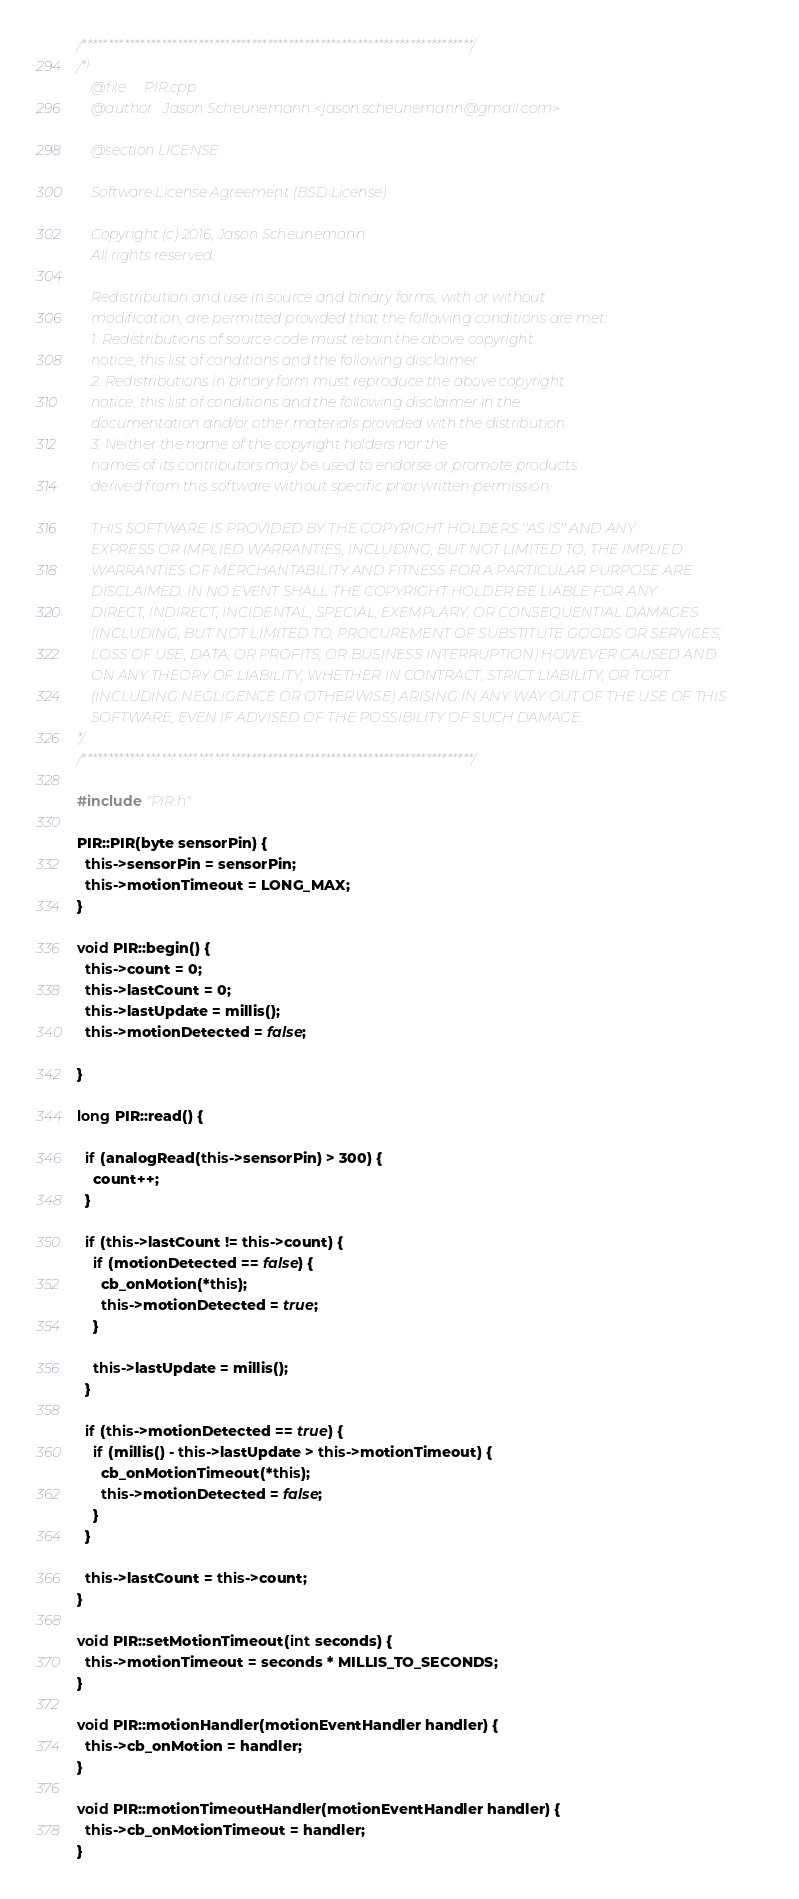Convert code to text. <code><loc_0><loc_0><loc_500><loc_500><_C++_>/**************************************************************************/
/*!
    @file     PIR.cpp
    @author   Jason Scheunemann <jason.scheunemann@gmail.com>

    @section LICENSE

    Software License Agreement (BSD License)

    Copyright (c) 2016, Jason Scheunemann
    All rights reserved.

    Redistribution and use in source and binary forms, with or without
    modification, are permitted provided that the following conditions are met:
    1. Redistributions of source code must retain the above copyright
    notice, this list of conditions and the following disclaimer.
    2. Redistributions in binary form must reproduce the above copyright
    notice, this list of conditions and the following disclaimer in the
    documentation and/or other materials provided with the distribution.
    3. Neither the name of the copyright holders nor the
    names of its contributors may be used to endorse or promote products
    derived from this software without specific prior written permission.

    THIS SOFTWARE IS PROVIDED BY THE COPYRIGHT HOLDERS ''AS IS'' AND ANY
    EXPRESS OR IMPLIED WARRANTIES, INCLUDING, BUT NOT LIMITED TO, THE IMPLIED
    WARRANTIES OF MERCHANTABILITY AND FITNESS FOR A PARTICULAR PURPOSE ARE
    DISCLAIMED. IN NO EVENT SHALL THE COPYRIGHT HOLDER BE LIABLE FOR ANY
    DIRECT, INDIRECT, INCIDENTAL, SPECIAL, EXEMPLARY, OR CONSEQUENTIAL DAMAGES
    (INCLUDING, BUT NOT LIMITED TO, PROCUREMENT OF SUBSTITUTE GOODS OR SERVICES;
    LOSS OF USE, DATA, OR PROFITS; OR BUSINESS INTERRUPTION) HOWEVER CAUSED AND
    ON ANY THEORY OF LIABILITY, WHETHER IN CONTRACT, STRICT LIABILITY, OR TORT
    (INCLUDING NEGLIGENCE OR OTHERWISE) ARISING IN ANY WAY OUT OF THE USE OF THIS
    SOFTWARE, EVEN IF ADVISED OF THE POSSIBILITY OF SUCH DAMAGE.
*/
/**************************************************************************/

#include "PIR.h"

PIR::PIR(byte sensorPin) {
  this->sensorPin = sensorPin;
  this->motionTimeout = LONG_MAX;
}

void PIR::begin() {
  this->count = 0;
  this->lastCount = 0;
  this->lastUpdate = millis();
  this->motionDetected = false;

}

long PIR::read() {

  if (analogRead(this->sensorPin) > 300) {
    count++;
  }

  if (this->lastCount != this->count) {
    if (motionDetected == false) {
      cb_onMotion(*this);
      this->motionDetected = true;
    }

    this->lastUpdate = millis();
  }

  if (this->motionDetected == true) {
    if (millis() - this->lastUpdate > this->motionTimeout) {
      cb_onMotionTimeout(*this);
      this->motionDetected = false;
    }
  }

  this->lastCount = this->count;
}

void PIR::setMotionTimeout(int seconds) {
  this->motionTimeout = seconds * MILLIS_TO_SECONDS;
}

void PIR::motionHandler(motionEventHandler handler) {
  this->cb_onMotion = handler;
}

void PIR::motionTimeoutHandler(motionEventHandler handler) {
  this->cb_onMotionTimeout = handler;
}
</code> 